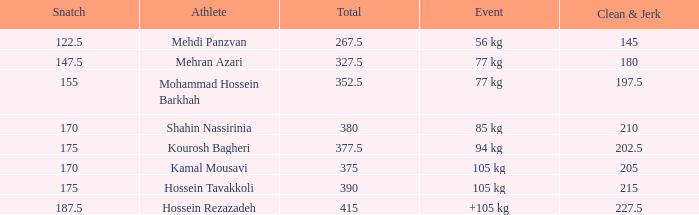What is the lowest total that had less than 170 snatches, 56 kg events and less than 145 clean & jerk? None. 